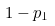Convert formula to latex. <formula><loc_0><loc_0><loc_500><loc_500>1 - p _ { 1 }</formula> 